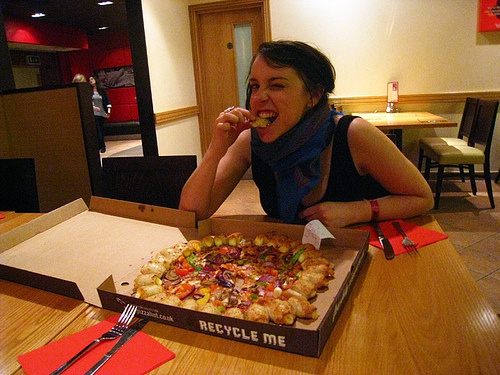Describe the objects in this image and their specific colors. I can see dining table in black, brown, maroon, and tan tones, people in black, maroon, and brown tones, pizza in black, brown, maroon, and tan tones, chair in black, olive, and maroon tones, and chair in black, maroon, and tan tones in this image. 